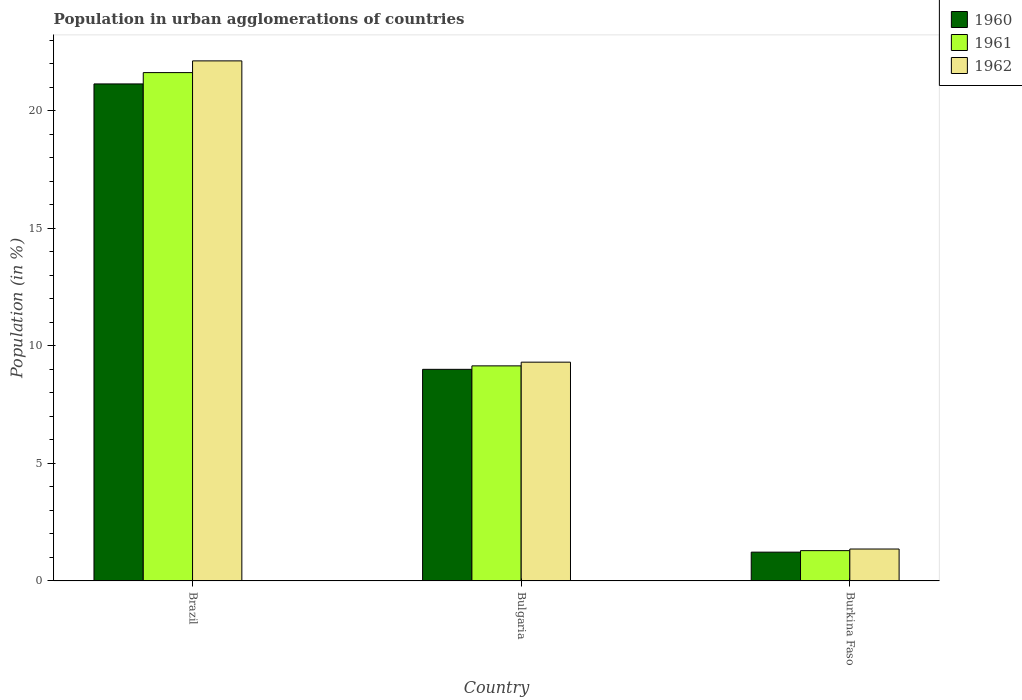How many different coloured bars are there?
Offer a very short reply. 3. Are the number of bars on each tick of the X-axis equal?
Provide a short and direct response. Yes. How many bars are there on the 1st tick from the left?
Make the answer very short. 3. What is the label of the 3rd group of bars from the left?
Give a very brief answer. Burkina Faso. What is the percentage of population in urban agglomerations in 1961 in Burkina Faso?
Your answer should be compact. 1.29. Across all countries, what is the maximum percentage of population in urban agglomerations in 1962?
Make the answer very short. 22.12. Across all countries, what is the minimum percentage of population in urban agglomerations in 1960?
Your answer should be very brief. 1.22. In which country was the percentage of population in urban agglomerations in 1960 minimum?
Make the answer very short. Burkina Faso. What is the total percentage of population in urban agglomerations in 1960 in the graph?
Ensure brevity in your answer.  31.36. What is the difference between the percentage of population in urban agglomerations in 1961 in Bulgaria and that in Burkina Faso?
Keep it short and to the point. 7.86. What is the difference between the percentage of population in urban agglomerations in 1962 in Bulgaria and the percentage of population in urban agglomerations in 1961 in Burkina Faso?
Your answer should be compact. 8.02. What is the average percentage of population in urban agglomerations in 1961 per country?
Offer a terse response. 10.69. What is the difference between the percentage of population in urban agglomerations of/in 1962 and percentage of population in urban agglomerations of/in 1960 in Bulgaria?
Provide a short and direct response. 0.3. In how many countries, is the percentage of population in urban agglomerations in 1962 greater than 9 %?
Your answer should be compact. 2. What is the ratio of the percentage of population in urban agglomerations in 1961 in Brazil to that in Burkina Faso?
Your response must be concise. 16.77. Is the percentage of population in urban agglomerations in 1961 in Brazil less than that in Burkina Faso?
Your response must be concise. No. What is the difference between the highest and the second highest percentage of population in urban agglomerations in 1961?
Make the answer very short. -12.47. What is the difference between the highest and the lowest percentage of population in urban agglomerations in 1962?
Your answer should be very brief. 20.76. What does the 2nd bar from the right in Bulgaria represents?
Your answer should be compact. 1961. Is it the case that in every country, the sum of the percentage of population in urban agglomerations in 1962 and percentage of population in urban agglomerations in 1961 is greater than the percentage of population in urban agglomerations in 1960?
Keep it short and to the point. Yes. How many bars are there?
Give a very brief answer. 9. How many countries are there in the graph?
Give a very brief answer. 3. What is the difference between two consecutive major ticks on the Y-axis?
Offer a terse response. 5. Are the values on the major ticks of Y-axis written in scientific E-notation?
Your response must be concise. No. Does the graph contain grids?
Your answer should be very brief. No. Where does the legend appear in the graph?
Your response must be concise. Top right. How many legend labels are there?
Your response must be concise. 3. What is the title of the graph?
Keep it short and to the point. Population in urban agglomerations of countries. What is the label or title of the Y-axis?
Provide a succinct answer. Population (in %). What is the Population (in %) of 1960 in Brazil?
Provide a short and direct response. 21.14. What is the Population (in %) of 1961 in Brazil?
Keep it short and to the point. 21.62. What is the Population (in %) in 1962 in Brazil?
Make the answer very short. 22.12. What is the Population (in %) of 1960 in Bulgaria?
Your response must be concise. 9. What is the Population (in %) in 1961 in Bulgaria?
Provide a succinct answer. 9.15. What is the Population (in %) in 1962 in Bulgaria?
Give a very brief answer. 9.3. What is the Population (in %) in 1960 in Burkina Faso?
Provide a succinct answer. 1.22. What is the Population (in %) in 1961 in Burkina Faso?
Give a very brief answer. 1.29. What is the Population (in %) of 1962 in Burkina Faso?
Provide a succinct answer. 1.36. Across all countries, what is the maximum Population (in %) in 1960?
Offer a very short reply. 21.14. Across all countries, what is the maximum Population (in %) of 1961?
Your answer should be compact. 21.62. Across all countries, what is the maximum Population (in %) of 1962?
Keep it short and to the point. 22.12. Across all countries, what is the minimum Population (in %) in 1960?
Keep it short and to the point. 1.22. Across all countries, what is the minimum Population (in %) of 1961?
Ensure brevity in your answer.  1.29. Across all countries, what is the minimum Population (in %) of 1962?
Provide a short and direct response. 1.36. What is the total Population (in %) in 1960 in the graph?
Your response must be concise. 31.36. What is the total Population (in %) in 1961 in the graph?
Offer a very short reply. 32.06. What is the total Population (in %) of 1962 in the graph?
Give a very brief answer. 32.78. What is the difference between the Population (in %) in 1960 in Brazil and that in Bulgaria?
Provide a short and direct response. 12.14. What is the difference between the Population (in %) of 1961 in Brazil and that in Bulgaria?
Give a very brief answer. 12.47. What is the difference between the Population (in %) in 1962 in Brazil and that in Bulgaria?
Your answer should be compact. 12.81. What is the difference between the Population (in %) of 1960 in Brazil and that in Burkina Faso?
Provide a succinct answer. 19.91. What is the difference between the Population (in %) of 1961 in Brazil and that in Burkina Faso?
Keep it short and to the point. 20.33. What is the difference between the Population (in %) of 1962 in Brazil and that in Burkina Faso?
Provide a succinct answer. 20.76. What is the difference between the Population (in %) of 1960 in Bulgaria and that in Burkina Faso?
Offer a very short reply. 7.78. What is the difference between the Population (in %) in 1961 in Bulgaria and that in Burkina Faso?
Keep it short and to the point. 7.86. What is the difference between the Population (in %) in 1962 in Bulgaria and that in Burkina Faso?
Provide a succinct answer. 7.95. What is the difference between the Population (in %) in 1960 in Brazil and the Population (in %) in 1961 in Bulgaria?
Keep it short and to the point. 11.99. What is the difference between the Population (in %) in 1960 in Brazil and the Population (in %) in 1962 in Bulgaria?
Make the answer very short. 11.83. What is the difference between the Population (in %) of 1961 in Brazil and the Population (in %) of 1962 in Bulgaria?
Provide a short and direct response. 12.32. What is the difference between the Population (in %) in 1960 in Brazil and the Population (in %) in 1961 in Burkina Faso?
Offer a terse response. 19.85. What is the difference between the Population (in %) of 1960 in Brazil and the Population (in %) of 1962 in Burkina Faso?
Make the answer very short. 19.78. What is the difference between the Population (in %) in 1961 in Brazil and the Population (in %) in 1962 in Burkina Faso?
Make the answer very short. 20.26. What is the difference between the Population (in %) of 1960 in Bulgaria and the Population (in %) of 1961 in Burkina Faso?
Your answer should be very brief. 7.71. What is the difference between the Population (in %) of 1960 in Bulgaria and the Population (in %) of 1962 in Burkina Faso?
Offer a terse response. 7.64. What is the difference between the Population (in %) in 1961 in Bulgaria and the Population (in %) in 1962 in Burkina Faso?
Offer a very short reply. 7.79. What is the average Population (in %) of 1960 per country?
Make the answer very short. 10.45. What is the average Population (in %) of 1961 per country?
Make the answer very short. 10.69. What is the average Population (in %) of 1962 per country?
Provide a succinct answer. 10.93. What is the difference between the Population (in %) of 1960 and Population (in %) of 1961 in Brazil?
Give a very brief answer. -0.48. What is the difference between the Population (in %) of 1960 and Population (in %) of 1962 in Brazil?
Ensure brevity in your answer.  -0.98. What is the difference between the Population (in %) in 1961 and Population (in %) in 1962 in Brazil?
Your answer should be very brief. -0.5. What is the difference between the Population (in %) of 1960 and Population (in %) of 1961 in Bulgaria?
Offer a terse response. -0.15. What is the difference between the Population (in %) in 1960 and Population (in %) in 1962 in Bulgaria?
Give a very brief answer. -0.3. What is the difference between the Population (in %) of 1961 and Population (in %) of 1962 in Bulgaria?
Ensure brevity in your answer.  -0.16. What is the difference between the Population (in %) in 1960 and Population (in %) in 1961 in Burkina Faso?
Make the answer very short. -0.06. What is the difference between the Population (in %) in 1960 and Population (in %) in 1962 in Burkina Faso?
Your response must be concise. -0.13. What is the difference between the Population (in %) in 1961 and Population (in %) in 1962 in Burkina Faso?
Your response must be concise. -0.07. What is the ratio of the Population (in %) in 1960 in Brazil to that in Bulgaria?
Make the answer very short. 2.35. What is the ratio of the Population (in %) of 1961 in Brazil to that in Bulgaria?
Ensure brevity in your answer.  2.36. What is the ratio of the Population (in %) in 1962 in Brazil to that in Bulgaria?
Provide a succinct answer. 2.38. What is the ratio of the Population (in %) of 1960 in Brazil to that in Burkina Faso?
Offer a terse response. 17.27. What is the ratio of the Population (in %) of 1961 in Brazil to that in Burkina Faso?
Offer a very short reply. 16.77. What is the ratio of the Population (in %) in 1962 in Brazil to that in Burkina Faso?
Your response must be concise. 16.3. What is the ratio of the Population (in %) of 1960 in Bulgaria to that in Burkina Faso?
Provide a short and direct response. 7.35. What is the ratio of the Population (in %) in 1961 in Bulgaria to that in Burkina Faso?
Your answer should be very brief. 7.1. What is the ratio of the Population (in %) in 1962 in Bulgaria to that in Burkina Faso?
Offer a very short reply. 6.86. What is the difference between the highest and the second highest Population (in %) in 1960?
Offer a very short reply. 12.14. What is the difference between the highest and the second highest Population (in %) in 1961?
Make the answer very short. 12.47. What is the difference between the highest and the second highest Population (in %) of 1962?
Your answer should be very brief. 12.81. What is the difference between the highest and the lowest Population (in %) in 1960?
Provide a succinct answer. 19.91. What is the difference between the highest and the lowest Population (in %) in 1961?
Provide a succinct answer. 20.33. What is the difference between the highest and the lowest Population (in %) of 1962?
Your response must be concise. 20.76. 